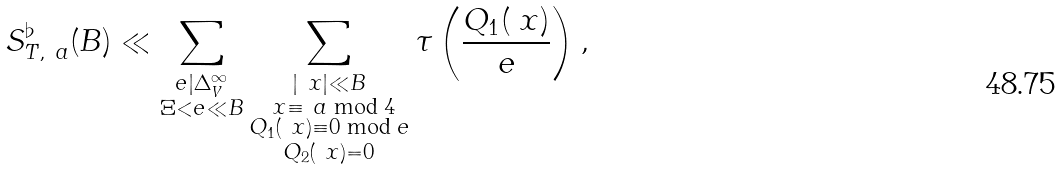Convert formula to latex. <formula><loc_0><loc_0><loc_500><loc_500>S _ { T , \ a } ^ { \flat } ( B ) & \ll \sum _ { \substack { e | \Delta _ { V } ^ { \infty } \\ \Xi < e \ll B } } \sum _ { \substack { | \ x | \ll B \\ \ x \equiv \ a \bmod { 4 } \\ Q _ { 1 } ( \ x ) \equiv 0 \bmod { e } \\ Q _ { 2 } ( \ x ) = 0 } } \tau \left ( \frac { Q _ { 1 } ( \ x ) } { e } \right ) ,</formula> 